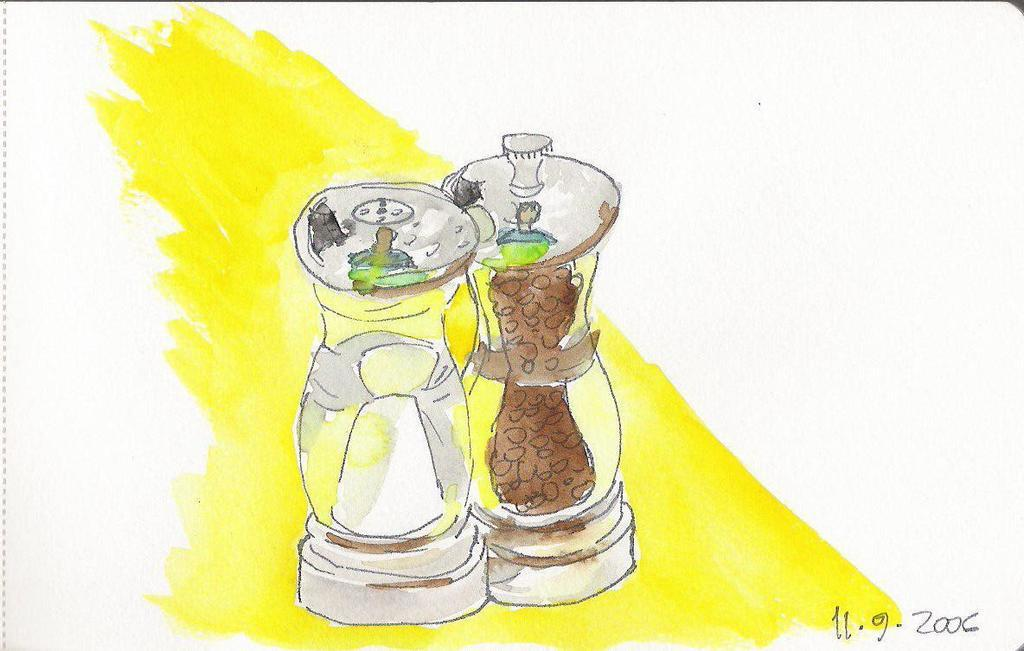<image>
Present a compact description of the photo's key features. A painting of a salt shaker and pepper grinder dated 11/9/2006 by the artist. 